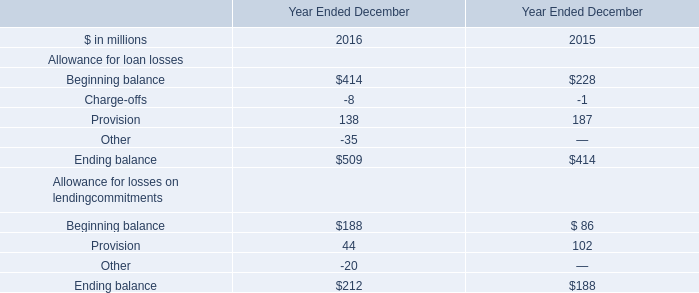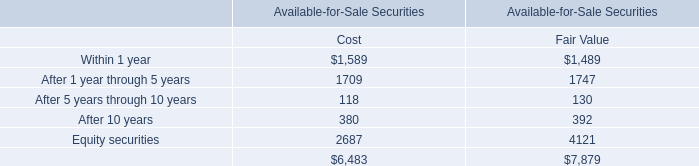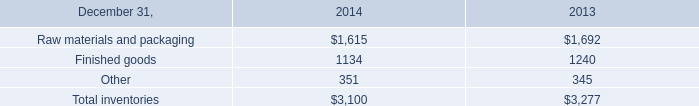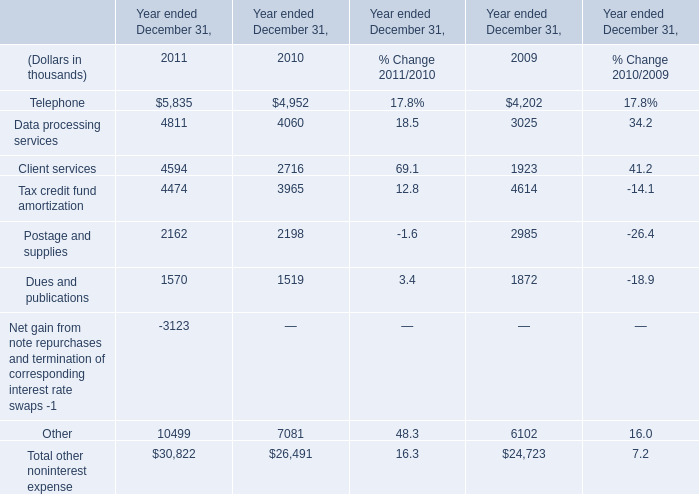What is the sum of Finished goods of 2013, Client services of Year ended December 31, 2011, and Data processing services of Year ended December 31, 2009 ? 
Computations: ((1240.0 + 4594.0) + 3025.0)
Answer: 8859.0. What is the sum of Client services of Year ended December 31, 2009, and Finished goods of 2013 ? 
Computations: (1923.0 + 1240.0)
Answer: 3163.0. 